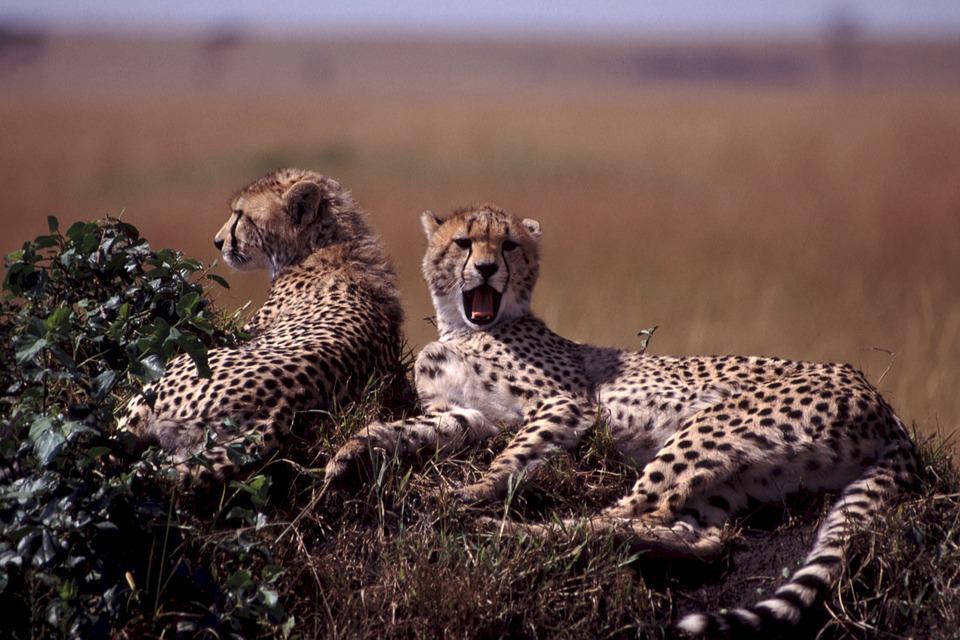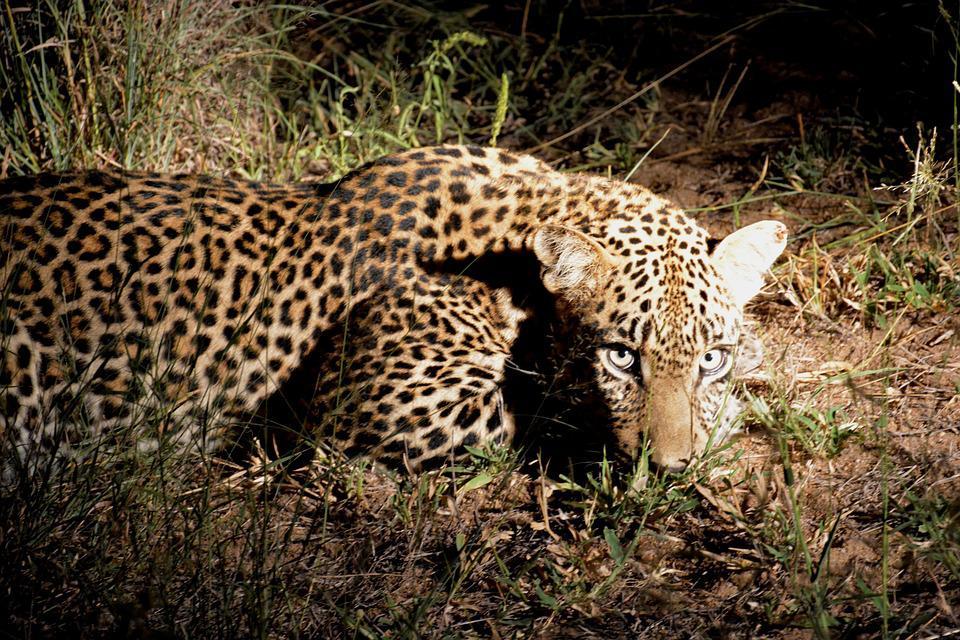The first image is the image on the left, the second image is the image on the right. Considering the images on both sides, is "The left image contains exactly two cheetahs." valid? Answer yes or no. Yes. The first image is the image on the left, the second image is the image on the right. Given the left and right images, does the statement "In two images two cheetahs are lying next to one another in the brown patchy grass." hold true? Answer yes or no. No. 